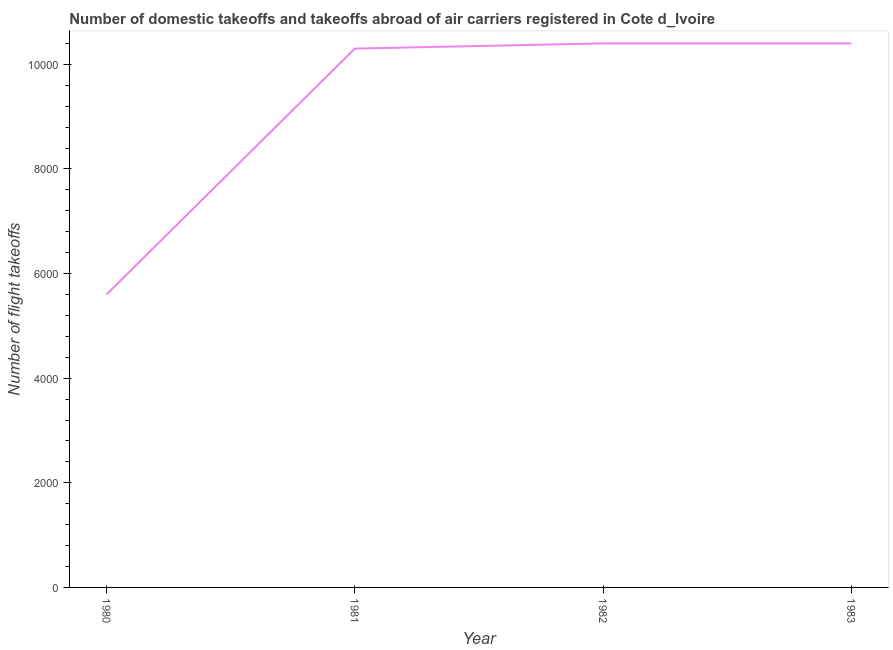What is the number of flight takeoffs in 1982?
Offer a very short reply. 1.04e+04. Across all years, what is the maximum number of flight takeoffs?
Provide a short and direct response. 1.04e+04. Across all years, what is the minimum number of flight takeoffs?
Offer a very short reply. 5600. In which year was the number of flight takeoffs maximum?
Give a very brief answer. 1982. In which year was the number of flight takeoffs minimum?
Ensure brevity in your answer.  1980. What is the sum of the number of flight takeoffs?
Provide a succinct answer. 3.67e+04. What is the difference between the number of flight takeoffs in 1980 and 1983?
Provide a succinct answer. -4800. What is the average number of flight takeoffs per year?
Make the answer very short. 9175. What is the median number of flight takeoffs?
Your answer should be compact. 1.04e+04. In how many years, is the number of flight takeoffs greater than 1200 ?
Offer a very short reply. 4. Do a majority of the years between 1981 and 1983 (inclusive) have number of flight takeoffs greater than 4800 ?
Ensure brevity in your answer.  Yes. What is the ratio of the number of flight takeoffs in 1981 to that in 1983?
Make the answer very short. 0.99. Is the difference between the number of flight takeoffs in 1980 and 1982 greater than the difference between any two years?
Ensure brevity in your answer.  Yes. What is the difference between the highest and the second highest number of flight takeoffs?
Give a very brief answer. 0. What is the difference between the highest and the lowest number of flight takeoffs?
Give a very brief answer. 4800. In how many years, is the number of flight takeoffs greater than the average number of flight takeoffs taken over all years?
Offer a terse response. 3. How many lines are there?
Your answer should be compact. 1. Does the graph contain any zero values?
Make the answer very short. No. What is the title of the graph?
Offer a terse response. Number of domestic takeoffs and takeoffs abroad of air carriers registered in Cote d_Ivoire. What is the label or title of the X-axis?
Make the answer very short. Year. What is the label or title of the Y-axis?
Keep it short and to the point. Number of flight takeoffs. What is the Number of flight takeoffs of 1980?
Provide a short and direct response. 5600. What is the Number of flight takeoffs in 1981?
Offer a terse response. 1.03e+04. What is the Number of flight takeoffs in 1982?
Keep it short and to the point. 1.04e+04. What is the Number of flight takeoffs in 1983?
Give a very brief answer. 1.04e+04. What is the difference between the Number of flight takeoffs in 1980 and 1981?
Provide a short and direct response. -4700. What is the difference between the Number of flight takeoffs in 1980 and 1982?
Offer a very short reply. -4800. What is the difference between the Number of flight takeoffs in 1980 and 1983?
Ensure brevity in your answer.  -4800. What is the difference between the Number of flight takeoffs in 1981 and 1982?
Provide a succinct answer. -100. What is the difference between the Number of flight takeoffs in 1981 and 1983?
Make the answer very short. -100. What is the ratio of the Number of flight takeoffs in 1980 to that in 1981?
Give a very brief answer. 0.54. What is the ratio of the Number of flight takeoffs in 1980 to that in 1982?
Ensure brevity in your answer.  0.54. What is the ratio of the Number of flight takeoffs in 1980 to that in 1983?
Your answer should be compact. 0.54. What is the ratio of the Number of flight takeoffs in 1981 to that in 1982?
Offer a very short reply. 0.99. What is the ratio of the Number of flight takeoffs in 1982 to that in 1983?
Your response must be concise. 1. 